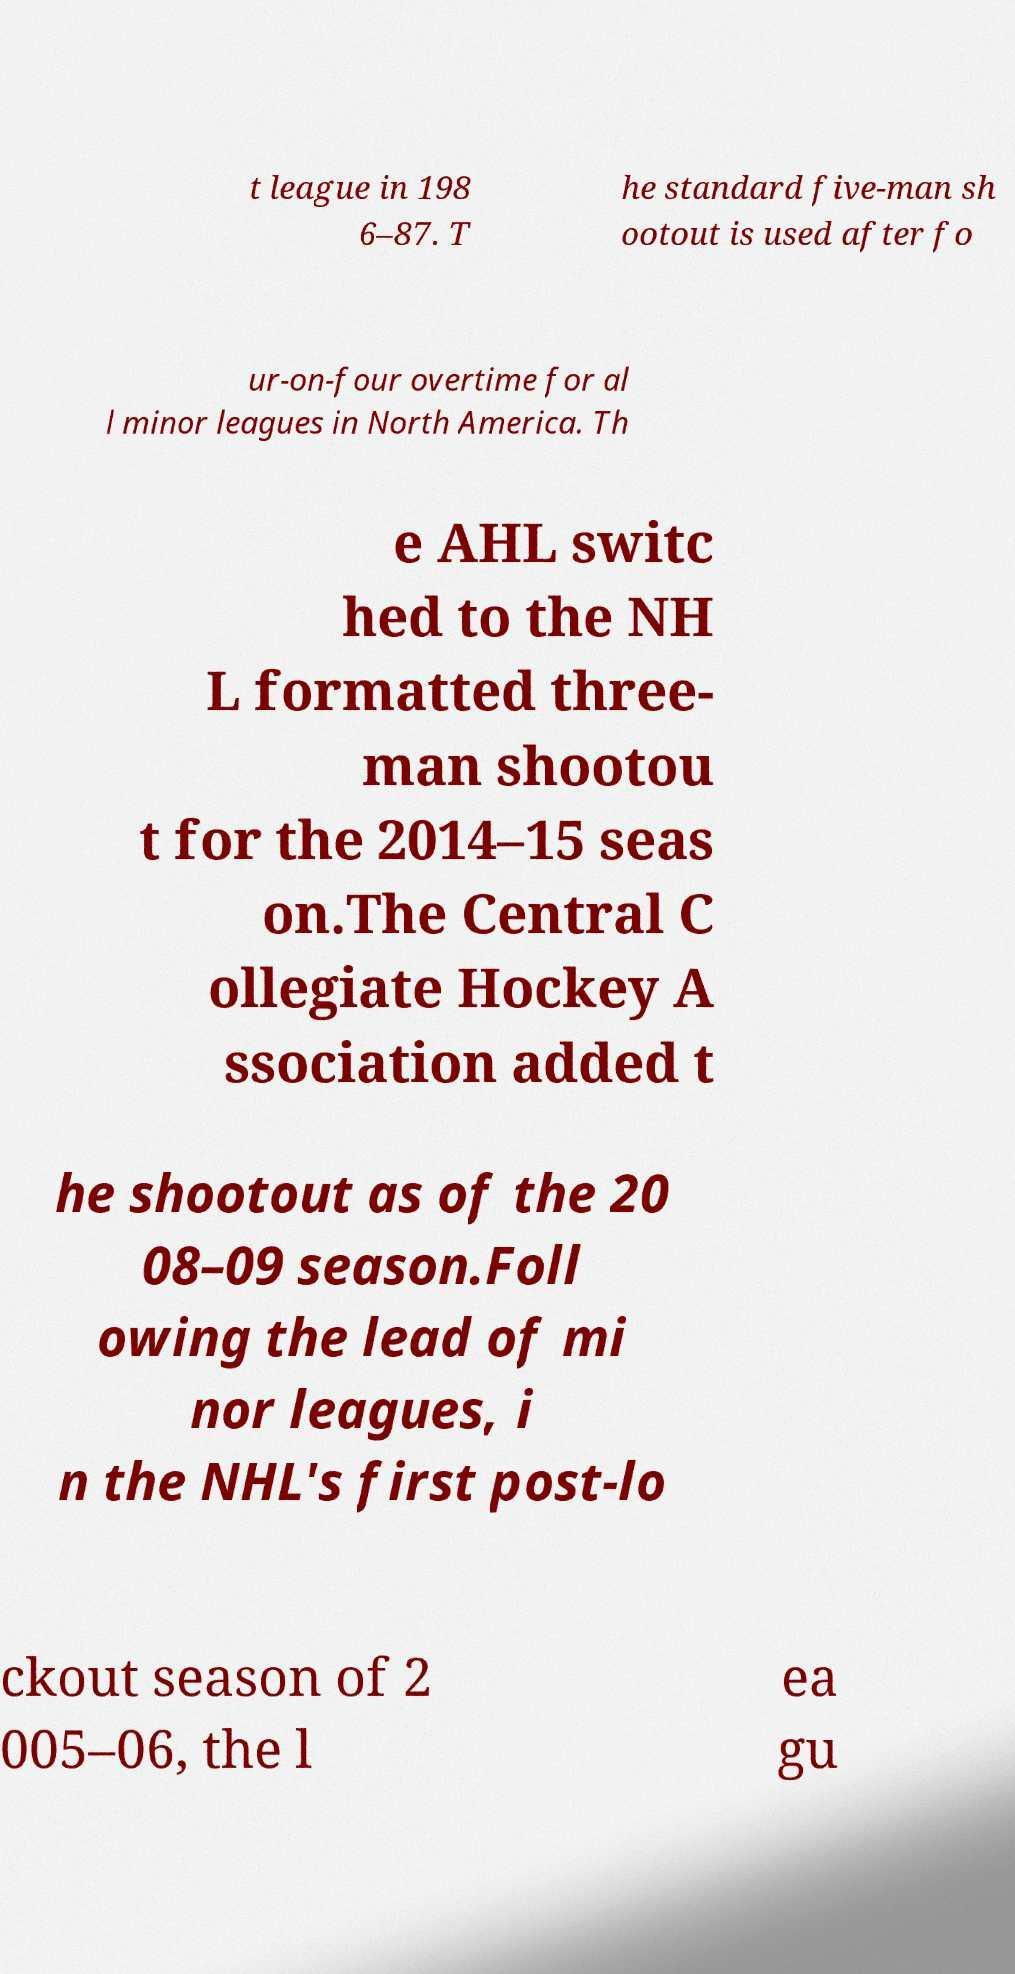Please read and relay the text visible in this image. What does it say? t league in 198 6–87. T he standard five-man sh ootout is used after fo ur-on-four overtime for al l minor leagues in North America. Th e AHL switc hed to the NH L formatted three- man shootou t for the 2014–15 seas on.The Central C ollegiate Hockey A ssociation added t he shootout as of the 20 08–09 season.Foll owing the lead of mi nor leagues, i n the NHL's first post-lo ckout season of 2 005–06, the l ea gu 